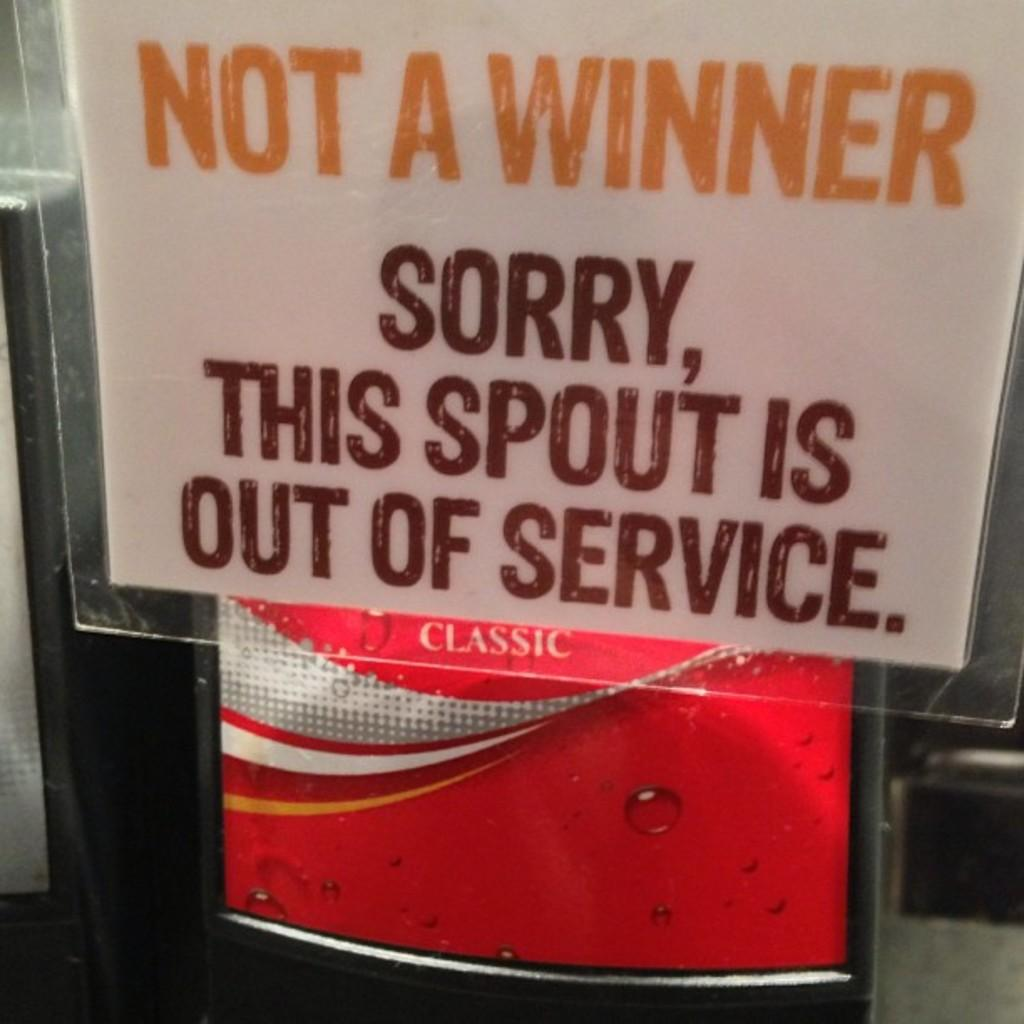What is the main object in the image? There is a board in the image. What material is the board made of? The board is made of glass. What can be seen on the surface of the board? There is text written on the board. What type of zipper can be seen on the back of the board in the image? There is no zipper present on the board in the image, as it is made of glass and not a garment or object with a zipper. 